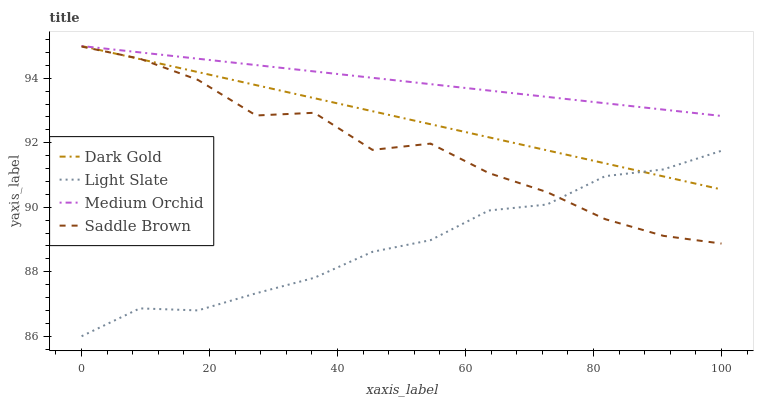Does Light Slate have the minimum area under the curve?
Answer yes or no. Yes. Does Medium Orchid have the maximum area under the curve?
Answer yes or no. Yes. Does Saddle Brown have the minimum area under the curve?
Answer yes or no. No. Does Saddle Brown have the maximum area under the curve?
Answer yes or no. No. Is Medium Orchid the smoothest?
Answer yes or no. Yes. Is Saddle Brown the roughest?
Answer yes or no. Yes. Is Saddle Brown the smoothest?
Answer yes or no. No. Is Medium Orchid the roughest?
Answer yes or no. No. Does Light Slate have the lowest value?
Answer yes or no. Yes. Does Saddle Brown have the lowest value?
Answer yes or no. No. Does Dark Gold have the highest value?
Answer yes or no. Yes. Does Saddle Brown have the highest value?
Answer yes or no. No. Is Light Slate less than Medium Orchid?
Answer yes or no. Yes. Is Medium Orchid greater than Light Slate?
Answer yes or no. Yes. Does Saddle Brown intersect Light Slate?
Answer yes or no. Yes. Is Saddle Brown less than Light Slate?
Answer yes or no. No. Is Saddle Brown greater than Light Slate?
Answer yes or no. No. Does Light Slate intersect Medium Orchid?
Answer yes or no. No. 